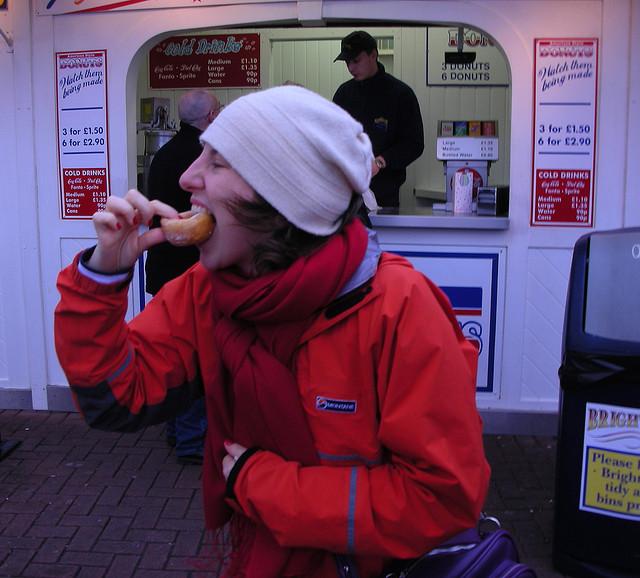What is in the lady's hand?
Give a very brief answer. Donut. What is this woman eating?
Answer briefly. Donut. What is covering the man's eyes?
Write a very short answer. Hat. What brand is on the girls shirt?
Short answer required. Pepsi. What is the man in the hooded jacket doing in this picture?
Quick response, please. Eating. What device is the woman holding?
Give a very brief answer. Donut. What color is her coat?
Be succinct. Red. Is the woman's mouth covered?
Be succinct. No. What is the style of the white hat called?
Short answer required. Beanie. What price is shown on the advertisement?
Keep it brief. 1.50. What direction is the lady looking?
Answer briefly. Left. What is the boy holding?
Answer briefly. Doughnut. What is she holding?
Keep it brief. Donut. What color is her hat?
Concise answer only. White. What kind of floor is this?
Give a very brief answer. Brick. How many people are in the background?
Quick response, please. 2. Is she using her phone?
Write a very short answer. No. How many caps in the picture?
Keep it brief. 2. Is this photo indoors?
Short answer required. No. What color is the man's hat?
Keep it brief. White. How many shirts is the woman wearing?
Concise answer only. 1. Is this indoors or outside?
Write a very short answer. Indoors. 